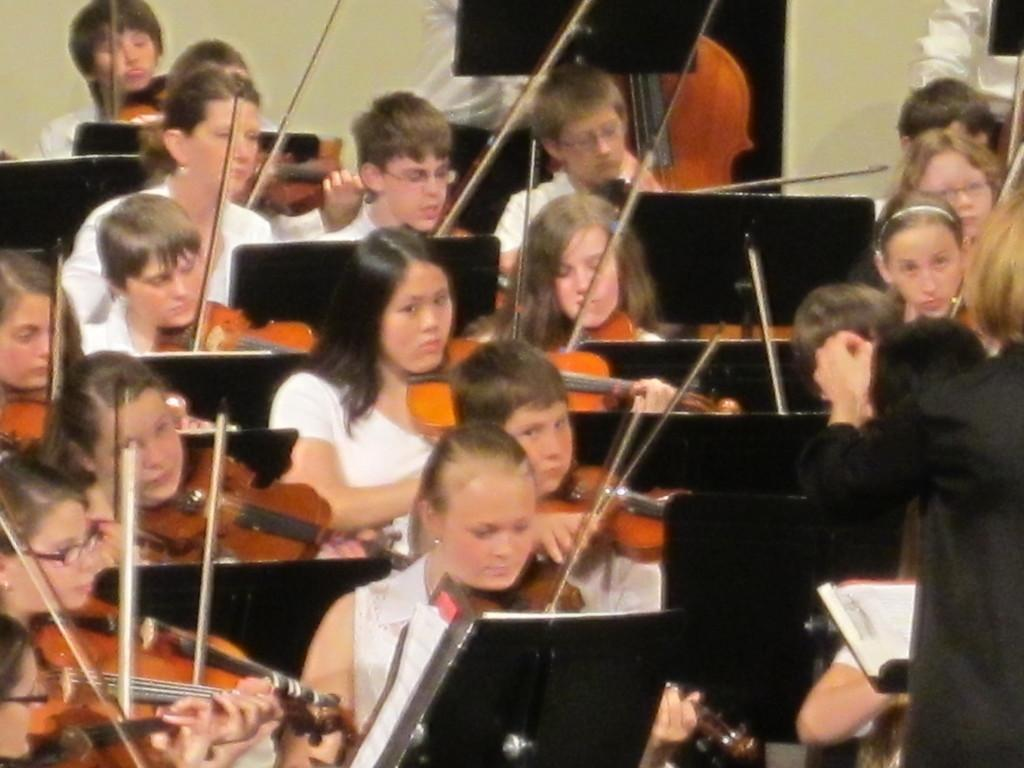How many kids are in the image? There is a group of kids in the image. What are the kids doing in the image? The kids are playing violins in the image. What might be the setting of the image? The image appears to be taken in a violin class. What type of bottle can be seen in the image? There is no bottle present in the image. Can you describe the detail of the bubble in the image? There is no bubble present in the image. 